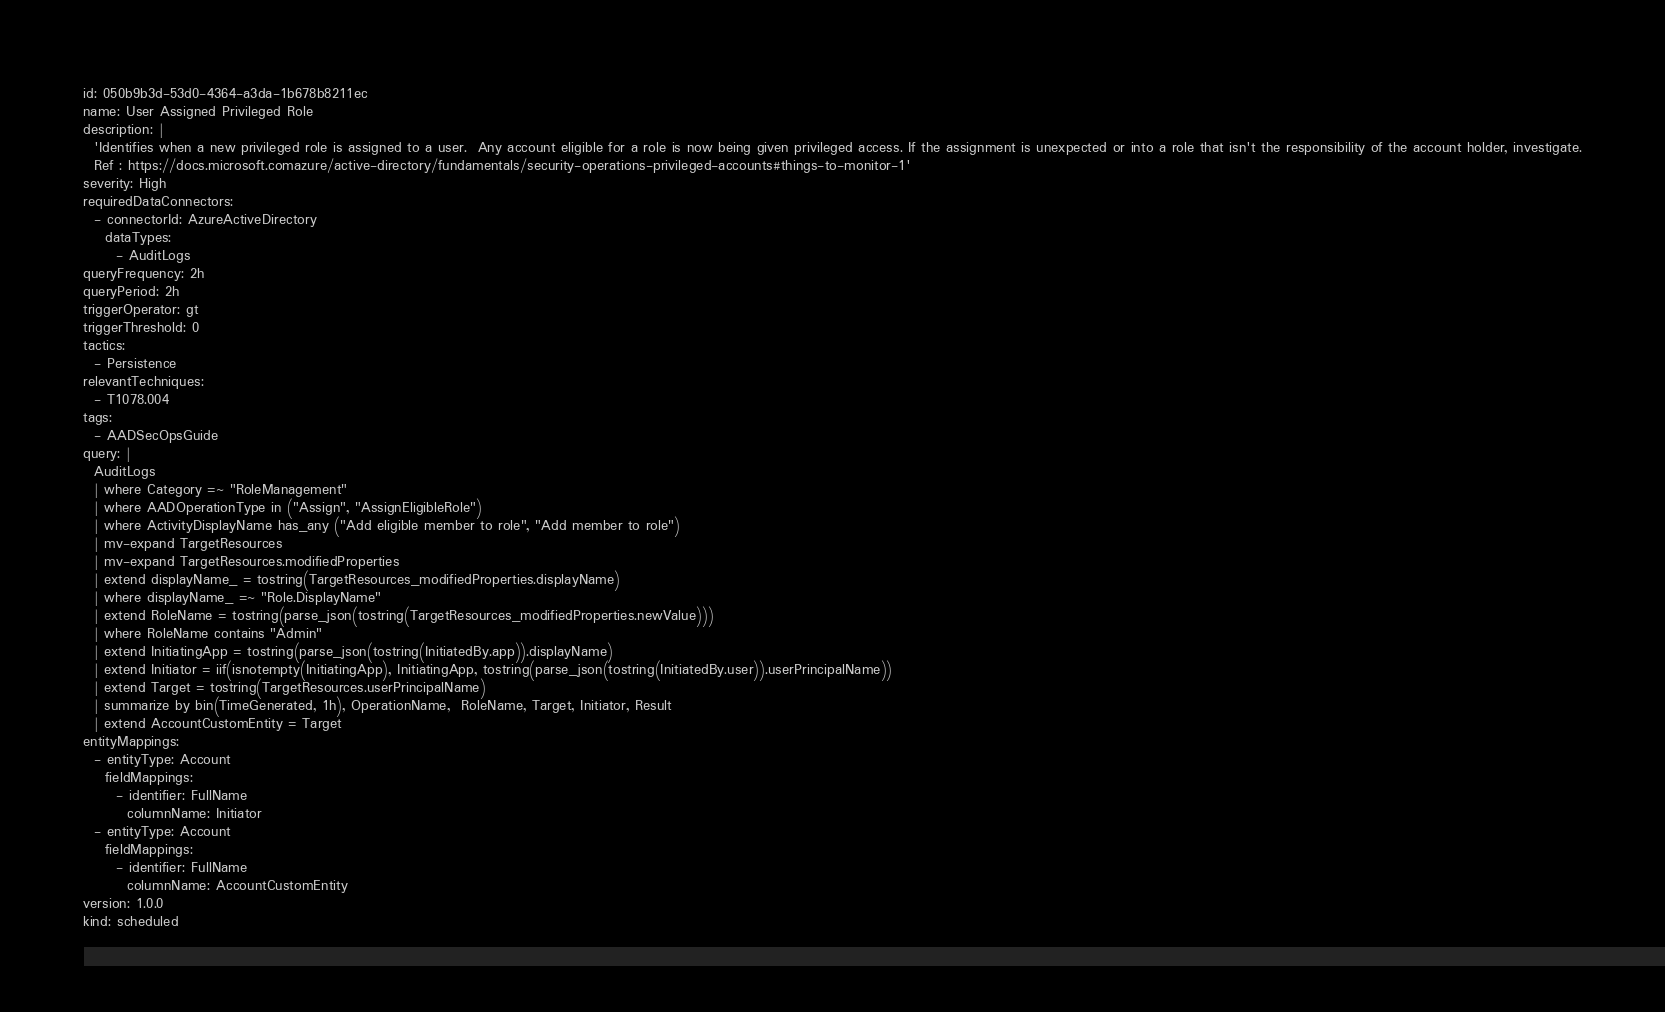<code> <loc_0><loc_0><loc_500><loc_500><_YAML_>id: 050b9b3d-53d0-4364-a3da-1b678b8211ec
name: User Assigned Privileged Role
description: |
  'Identifies when a new privileged role is assigned to a user.  Any account eligible for a role is now being given privileged access. If the assignment is unexpected or into a role that isn't the responsibility of the account holder, investigate.
  Ref : https://docs.microsoft.comazure/active-directory/fundamentals/security-operations-privileged-accounts#things-to-monitor-1'
severity: High
requiredDataConnectors:
  - connectorId: AzureActiveDirectory
    dataTypes:
      - AuditLogs
queryFrequency: 2h
queryPeriod: 2h
triggerOperator: gt
triggerThreshold: 0
tactics:
  - Persistence
relevantTechniques:
  - T1078.004
tags:
  - AADSecOpsGuide
query: |
  AuditLogs
  | where Category =~ "RoleManagement"
  | where AADOperationType in ("Assign", "AssignEligibleRole")
  | where ActivityDisplayName has_any ("Add eligible member to role", "Add member to role")
  | mv-expand TargetResources
  | mv-expand TargetResources.modifiedProperties
  | extend displayName_ = tostring(TargetResources_modifiedProperties.displayName)
  | where displayName_ =~ "Role.DisplayName"
  | extend RoleName = tostring(parse_json(tostring(TargetResources_modifiedProperties.newValue)))
  | where RoleName contains "Admin"
  | extend InitiatingApp = tostring(parse_json(tostring(InitiatedBy.app)).displayName)
  | extend Initiator = iif(isnotempty(InitiatingApp), InitiatingApp, tostring(parse_json(tostring(InitiatedBy.user)).userPrincipalName))
  | extend Target = tostring(TargetResources.userPrincipalName)
  | summarize by bin(TimeGenerated, 1h), OperationName,  RoleName, Target, Initiator, Result
  | extend AccountCustomEntity = Target
entityMappings:
  - entityType: Account
    fieldMappings:
      - identifier: FullName
        columnName: Initiator
  - entityType: Account
    fieldMappings:
      - identifier: FullName
        columnName: AccountCustomEntity
version: 1.0.0
kind: scheduled
</code> 